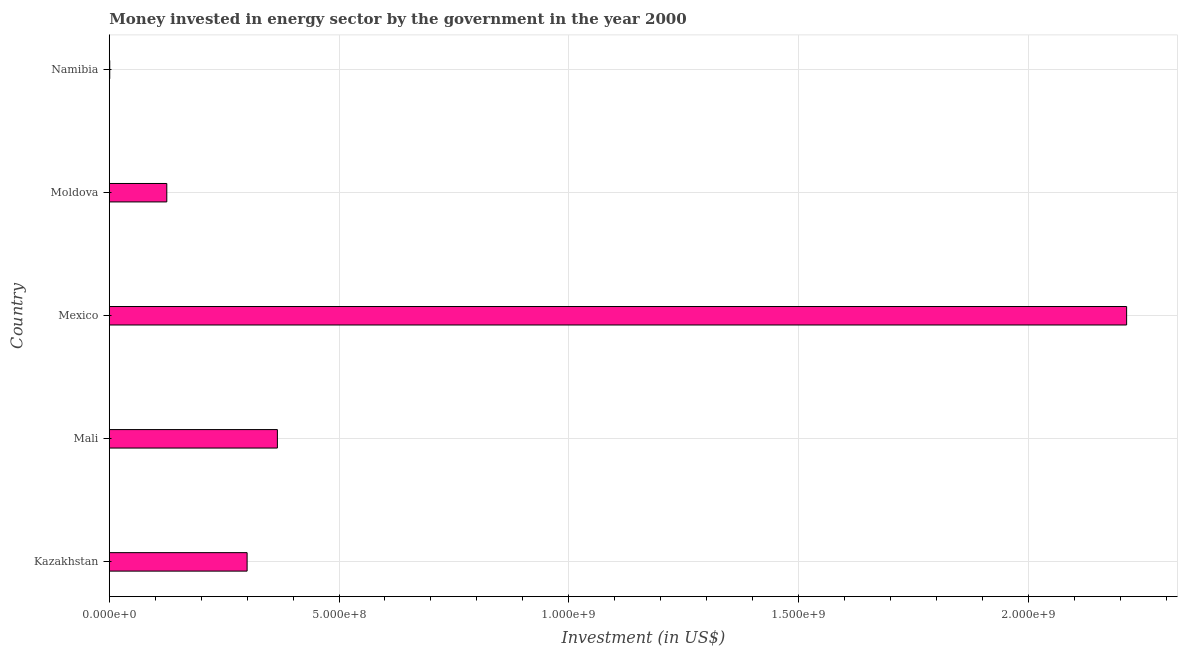Does the graph contain grids?
Keep it short and to the point. Yes. What is the title of the graph?
Provide a short and direct response. Money invested in energy sector by the government in the year 2000. What is the label or title of the X-axis?
Your answer should be very brief. Investment (in US$). What is the investment in energy in Moldova?
Your response must be concise. 1.25e+08. Across all countries, what is the maximum investment in energy?
Give a very brief answer. 2.21e+09. Across all countries, what is the minimum investment in energy?
Offer a very short reply. 1.00e+06. In which country was the investment in energy minimum?
Offer a terse response. Namibia. What is the sum of the investment in energy?
Ensure brevity in your answer.  3.01e+09. What is the difference between the investment in energy in Mali and Namibia?
Offer a terse response. 3.65e+08. What is the average investment in energy per country?
Keep it short and to the point. 6.01e+08. What is the median investment in energy?
Offer a terse response. 3.00e+08. In how many countries, is the investment in energy greater than 800000000 US$?
Give a very brief answer. 1. What is the ratio of the investment in energy in Kazakhstan to that in Mali?
Provide a short and direct response. 0.82. Is the investment in energy in Kazakhstan less than that in Moldova?
Keep it short and to the point. No. Is the difference between the investment in energy in Mali and Namibia greater than the difference between any two countries?
Keep it short and to the point. No. What is the difference between the highest and the second highest investment in energy?
Provide a succinct answer. 1.85e+09. What is the difference between the highest and the lowest investment in energy?
Give a very brief answer. 2.21e+09. Are all the bars in the graph horizontal?
Ensure brevity in your answer.  Yes. How many countries are there in the graph?
Make the answer very short. 5. What is the Investment (in US$) in Kazakhstan?
Provide a short and direct response. 3.00e+08. What is the Investment (in US$) in Mali?
Provide a short and direct response. 3.66e+08. What is the Investment (in US$) of Mexico?
Your response must be concise. 2.21e+09. What is the Investment (in US$) of Moldova?
Provide a short and direct response. 1.25e+08. What is the Investment (in US$) in Namibia?
Your response must be concise. 1.00e+06. What is the difference between the Investment (in US$) in Kazakhstan and Mali?
Make the answer very short. -6.59e+07. What is the difference between the Investment (in US$) in Kazakhstan and Mexico?
Your answer should be very brief. -1.91e+09. What is the difference between the Investment (in US$) in Kazakhstan and Moldova?
Keep it short and to the point. 1.75e+08. What is the difference between the Investment (in US$) in Kazakhstan and Namibia?
Give a very brief answer. 2.99e+08. What is the difference between the Investment (in US$) in Mali and Mexico?
Provide a succinct answer. -1.85e+09. What is the difference between the Investment (in US$) in Mali and Moldova?
Provide a succinct answer. 2.41e+08. What is the difference between the Investment (in US$) in Mali and Namibia?
Your answer should be very brief. 3.65e+08. What is the difference between the Investment (in US$) in Mexico and Moldova?
Your answer should be compact. 2.09e+09. What is the difference between the Investment (in US$) in Mexico and Namibia?
Your answer should be compact. 2.21e+09. What is the difference between the Investment (in US$) in Moldova and Namibia?
Ensure brevity in your answer.  1.24e+08. What is the ratio of the Investment (in US$) in Kazakhstan to that in Mali?
Your answer should be very brief. 0.82. What is the ratio of the Investment (in US$) in Kazakhstan to that in Mexico?
Make the answer very short. 0.14. What is the ratio of the Investment (in US$) in Kazakhstan to that in Moldova?
Offer a terse response. 2.4. What is the ratio of the Investment (in US$) in Kazakhstan to that in Namibia?
Keep it short and to the point. 300. What is the ratio of the Investment (in US$) in Mali to that in Mexico?
Provide a succinct answer. 0.17. What is the ratio of the Investment (in US$) in Mali to that in Moldova?
Your answer should be very brief. 2.92. What is the ratio of the Investment (in US$) in Mali to that in Namibia?
Keep it short and to the point. 365.9. What is the ratio of the Investment (in US$) in Mexico to that in Moldova?
Provide a succinct answer. 17.69. What is the ratio of the Investment (in US$) in Mexico to that in Namibia?
Make the answer very short. 2214.3. What is the ratio of the Investment (in US$) in Moldova to that in Namibia?
Your answer should be very brief. 125.2. 